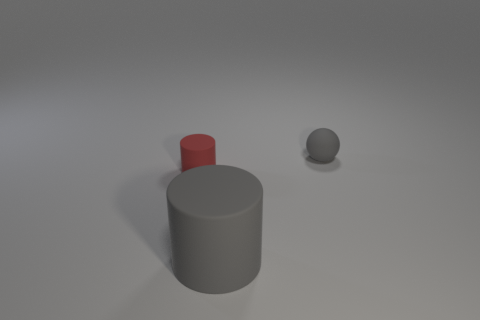How many objects are spheres or tiny matte things right of the gray cylinder?
Provide a succinct answer. 1. Do the gray thing that is in front of the red matte thing and the tiny red thing have the same size?
Your response must be concise. No. What material is the gray object that is behind the tiny red rubber object?
Your answer should be compact. Rubber. Are there the same number of large gray matte cylinders that are on the left side of the red thing and tiny red things in front of the gray matte cylinder?
Provide a succinct answer. Yes. There is a large matte thing that is the same shape as the small red matte object; what color is it?
Provide a short and direct response. Gray. Is there anything else that is the same color as the tiny cylinder?
Make the answer very short. No. How many matte things are tiny cylinders or cubes?
Your response must be concise. 1. Is the tiny ball the same color as the large cylinder?
Give a very brief answer. Yes. Are there more big gray rubber objects that are behind the red rubber cylinder than big blue rubber cylinders?
Provide a short and direct response. No. What number of large things are either red matte objects or green rubber cylinders?
Keep it short and to the point. 0. 